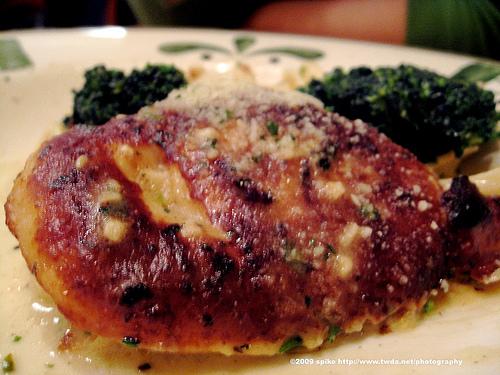What kind of cheese is on it?
Write a very short answer. Parmesan. Is this food?
Keep it brief. Yes. What vegetable comes with the dish?
Answer briefly. Broccoli. 